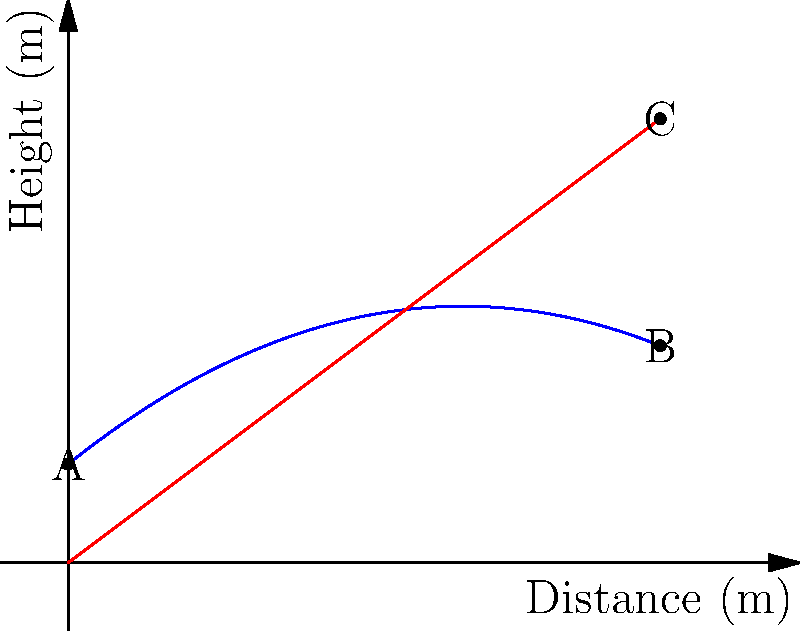In an MMA fight, Derrick Lewis throws a powerful punch. The trajectory of his fist can be modeled by the polynomial function $f(x) = -0.1x^2 + 0.8x + 1$, where $x$ is the horizontal distance traveled (in meters) and $f(x)$ is the height of his fist (in meters). If the punch travels a horizontal distance of 6 meters, how much higher does the fist reach compared to a straight-line punch at the same horizontal distance? To solve this problem, we'll follow these steps:

1) First, we need to find the height of the fist at 6 meters for the actual punch trajectory:
   $f(6) = -0.1(6)^2 + 0.8(6) + 1$
   $f(6) = -0.1(36) + 4.8 + 1$
   $f(6) = -3.6 + 4.8 + 1 = 2.2$ meters

2) Now, we need to calculate the height of a straight-line punch at 6 meters. A straight line from the starting point (0,1) to (6,y) can be represented by the function $g(x) = mx + 1$, where $m$ is the slope.

3) The slope $m$ can be calculated using the starting height (1 meter) and the horizontal distance (6 meters):
   $m = \frac{\text{rise}}{\text{run}} = \frac{1}{6} \approx 0.1667$

4) So, the height of a straight-line punch at 6 meters would be:
   $g(6) = 0.1667(6) + 1 = 2$ meters

5) The difference in height between the actual punch and the straight-line punch is:
   $2.2 - 2 = 0.2$ meters

Therefore, Derrick Lewis's fist reaches 0.2 meters (or 20 centimeters) higher than a straight-line punch at the same horizontal distance.
Answer: 0.2 meters 